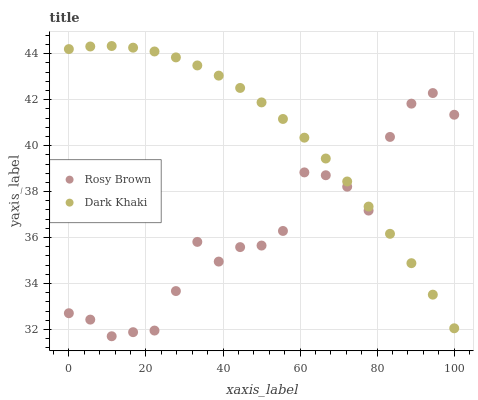Does Rosy Brown have the minimum area under the curve?
Answer yes or no. Yes. Does Dark Khaki have the maximum area under the curve?
Answer yes or no. Yes. Does Rosy Brown have the maximum area under the curve?
Answer yes or no. No. Is Dark Khaki the smoothest?
Answer yes or no. Yes. Is Rosy Brown the roughest?
Answer yes or no. Yes. Is Rosy Brown the smoothest?
Answer yes or no. No. Does Rosy Brown have the lowest value?
Answer yes or no. Yes. Does Dark Khaki have the highest value?
Answer yes or no. Yes. Does Rosy Brown have the highest value?
Answer yes or no. No. Does Rosy Brown intersect Dark Khaki?
Answer yes or no. Yes. Is Rosy Brown less than Dark Khaki?
Answer yes or no. No. Is Rosy Brown greater than Dark Khaki?
Answer yes or no. No. 